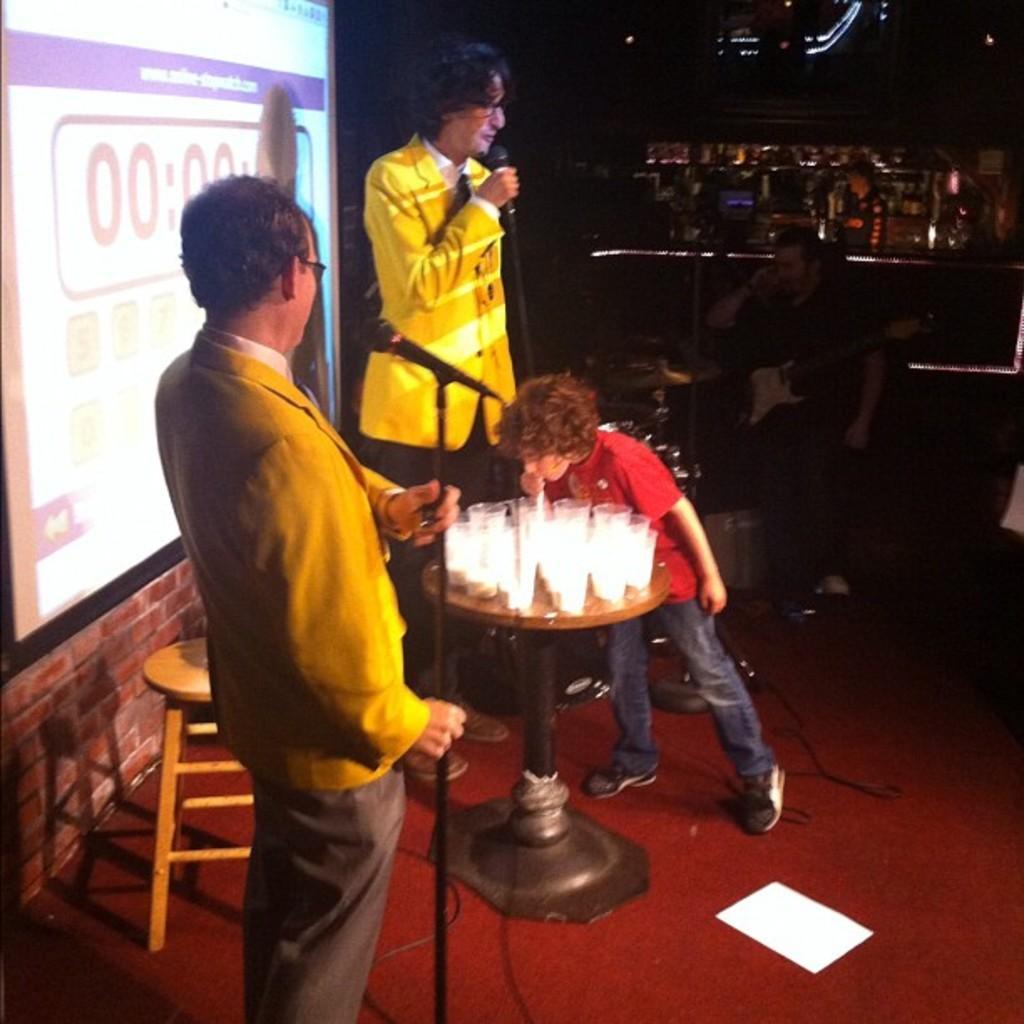How would you summarize this image in a sentence or two? Here we can see four persons and he is holding a mike with his hand. There are glasses, table, chair, paper, screen, mikes, and lights. There is a dark background. 